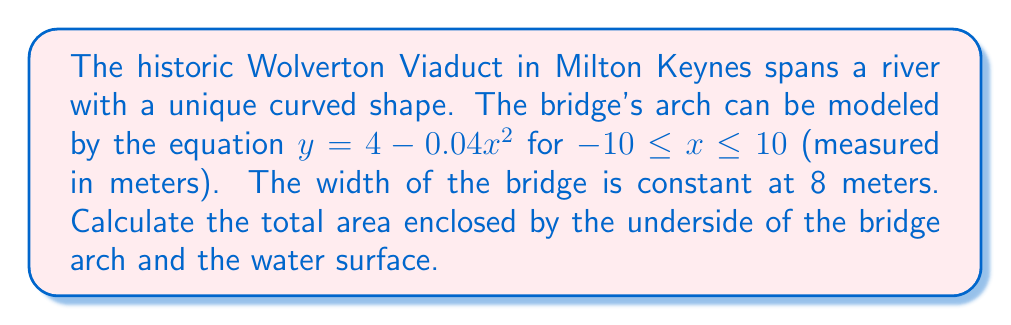Give your solution to this math problem. To solve this problem, we need to use a double integral to calculate the area enclosed by the bridge arch and the water surface. Let's approach this step-by-step:

1) The curve of the bridge arch is given by $y = 4 - 0.04x^2$ for $-10 \leq x \leq 10$.

2) The area we want to calculate is bounded by this curve above, the x-axis below (representing the water surface), and the vertical lines at $x = -10$ and $x = 10$.

3) We can set up a double integral to calculate this area:

   $$A = \int_{-10}^{10} \int_{0}^{4-0.04x^2} dy \, dx$$

4) Let's evaluate the inner integral first:

   $$A = \int_{-10}^{10} [y]_{0}^{4-0.04x^2} dx = \int_{-10}^{10} (4-0.04x^2) dx$$

5) Now we can evaluate the outer integral:

   $$A = \left[4x - \frac{0.04x^3}{3}\right]_{-10}^{10}$$

6) Substituting the limits:

   $$A = \left(40 - \frac{40}{3}\right) - \left(-40 - \frac{-40}{3}\right) = 40 - \frac{40}{3} + 40 + \frac{40}{3} = 80$$

7) Therefore, the area enclosed is 80 square meters.

8) However, remember that the bridge has a width of 8 meters. To get the total volume enclosed, we need to multiply our result by 8:

   Total Area = $80 \times 8 = 640$ square meters
Answer: The total area enclosed by the underside of the Wolverton Viaduct arch and the water surface is 640 square meters. 